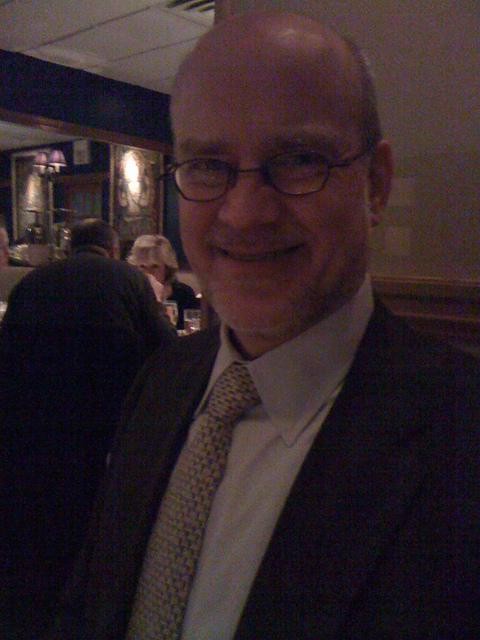What venue is the man in? Please explain your reasoning. restaurant. There are tables and he is in a booth. 